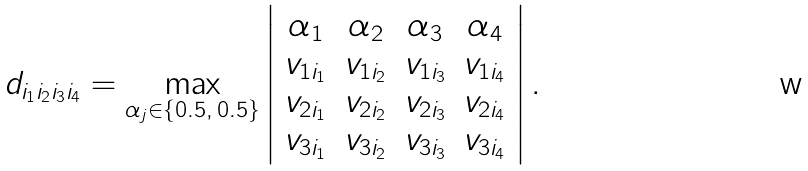Convert formula to latex. <formula><loc_0><loc_0><loc_500><loc_500>d _ { i _ { 1 } i _ { 2 } i _ { 3 } i _ { 4 } } = \max _ { \alpha _ { j } \in \{ 0 . 5 , \, 0 . 5 \} } \left | \begin{array} { c c c c } \alpha _ { 1 } & \alpha _ { 2 } & \alpha _ { 3 } & \alpha _ { 4 } \\ v _ { 1 i _ { 1 } } & v _ { 1 i _ { 2 } } & v _ { 1 i _ { 3 } } & v _ { 1 i _ { 4 } } \\ v _ { 2 i _ { 1 } } & v _ { 2 i _ { 2 } } & v _ { 2 i _ { 3 } } & v _ { 2 i _ { 4 } } \\ v _ { 3 i _ { 1 } } & v _ { 3 i _ { 2 } } & v _ { 3 i _ { 3 } } & v _ { 3 i _ { 4 } } \end{array} \right | .</formula> 